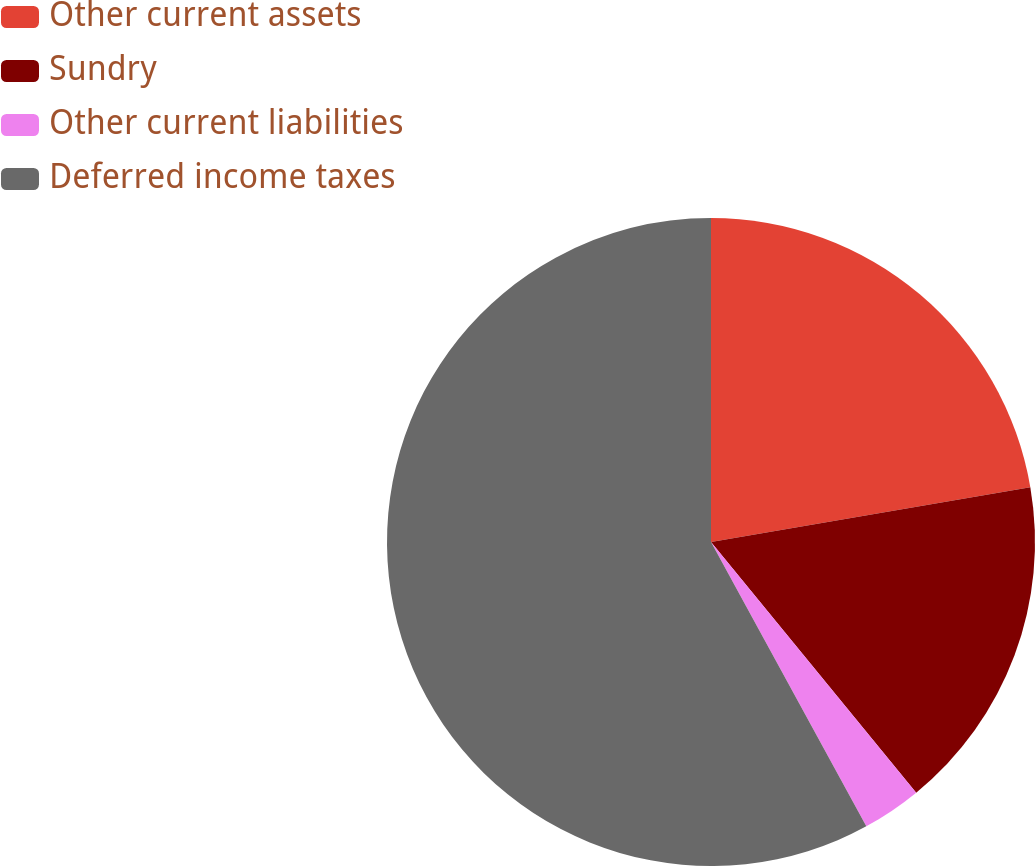<chart> <loc_0><loc_0><loc_500><loc_500><pie_chart><fcel>Other current assets<fcel>Sundry<fcel>Other current liabilities<fcel>Deferred income taxes<nl><fcel>22.29%<fcel>16.79%<fcel>2.96%<fcel>57.95%<nl></chart> 